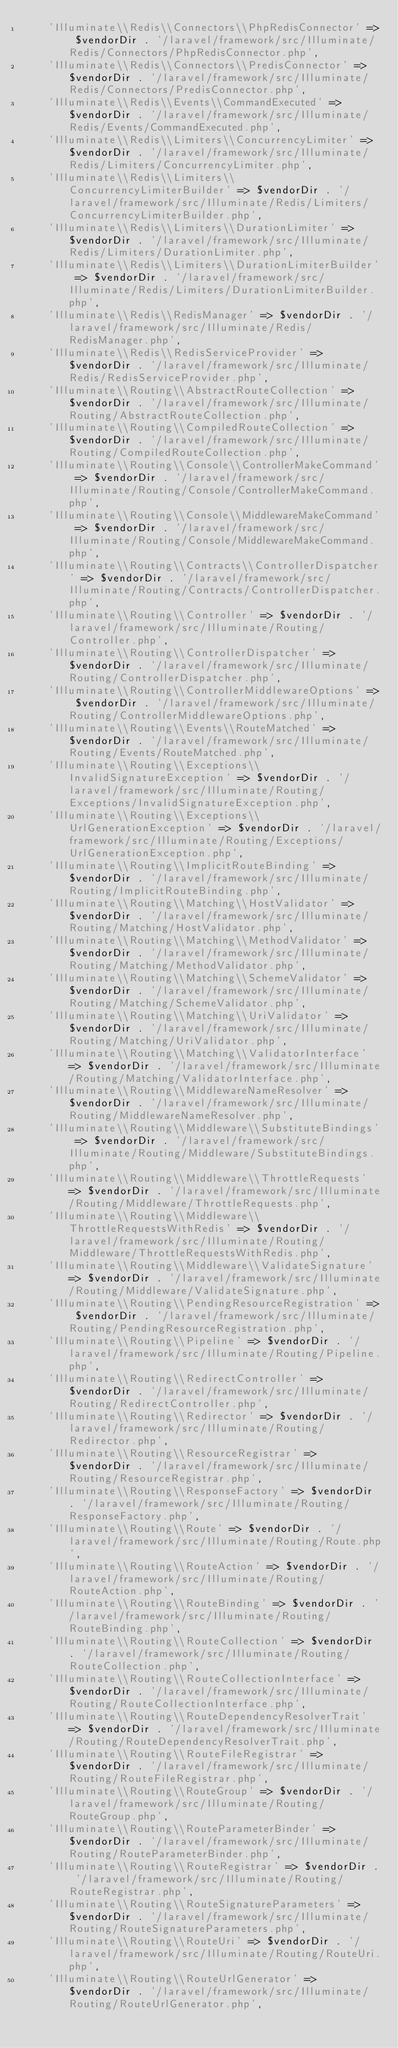Convert code to text. <code><loc_0><loc_0><loc_500><loc_500><_PHP_>    'Illuminate\\Redis\\Connectors\\PhpRedisConnector' => $vendorDir . '/laravel/framework/src/Illuminate/Redis/Connectors/PhpRedisConnector.php',
    'Illuminate\\Redis\\Connectors\\PredisConnector' => $vendorDir . '/laravel/framework/src/Illuminate/Redis/Connectors/PredisConnector.php',
    'Illuminate\\Redis\\Events\\CommandExecuted' => $vendorDir . '/laravel/framework/src/Illuminate/Redis/Events/CommandExecuted.php',
    'Illuminate\\Redis\\Limiters\\ConcurrencyLimiter' => $vendorDir . '/laravel/framework/src/Illuminate/Redis/Limiters/ConcurrencyLimiter.php',
    'Illuminate\\Redis\\Limiters\\ConcurrencyLimiterBuilder' => $vendorDir . '/laravel/framework/src/Illuminate/Redis/Limiters/ConcurrencyLimiterBuilder.php',
    'Illuminate\\Redis\\Limiters\\DurationLimiter' => $vendorDir . '/laravel/framework/src/Illuminate/Redis/Limiters/DurationLimiter.php',
    'Illuminate\\Redis\\Limiters\\DurationLimiterBuilder' => $vendorDir . '/laravel/framework/src/Illuminate/Redis/Limiters/DurationLimiterBuilder.php',
    'Illuminate\\Redis\\RedisManager' => $vendorDir . '/laravel/framework/src/Illuminate/Redis/RedisManager.php',
    'Illuminate\\Redis\\RedisServiceProvider' => $vendorDir . '/laravel/framework/src/Illuminate/Redis/RedisServiceProvider.php',
    'Illuminate\\Routing\\AbstractRouteCollection' => $vendorDir . '/laravel/framework/src/Illuminate/Routing/AbstractRouteCollection.php',
    'Illuminate\\Routing\\CompiledRouteCollection' => $vendorDir . '/laravel/framework/src/Illuminate/Routing/CompiledRouteCollection.php',
    'Illuminate\\Routing\\Console\\ControllerMakeCommand' => $vendorDir . '/laravel/framework/src/Illuminate/Routing/Console/ControllerMakeCommand.php',
    'Illuminate\\Routing\\Console\\MiddlewareMakeCommand' => $vendorDir . '/laravel/framework/src/Illuminate/Routing/Console/MiddlewareMakeCommand.php',
    'Illuminate\\Routing\\Contracts\\ControllerDispatcher' => $vendorDir . '/laravel/framework/src/Illuminate/Routing/Contracts/ControllerDispatcher.php',
    'Illuminate\\Routing\\Controller' => $vendorDir . '/laravel/framework/src/Illuminate/Routing/Controller.php',
    'Illuminate\\Routing\\ControllerDispatcher' => $vendorDir . '/laravel/framework/src/Illuminate/Routing/ControllerDispatcher.php',
    'Illuminate\\Routing\\ControllerMiddlewareOptions' => $vendorDir . '/laravel/framework/src/Illuminate/Routing/ControllerMiddlewareOptions.php',
    'Illuminate\\Routing\\Events\\RouteMatched' => $vendorDir . '/laravel/framework/src/Illuminate/Routing/Events/RouteMatched.php',
    'Illuminate\\Routing\\Exceptions\\InvalidSignatureException' => $vendorDir . '/laravel/framework/src/Illuminate/Routing/Exceptions/InvalidSignatureException.php',
    'Illuminate\\Routing\\Exceptions\\UrlGenerationException' => $vendorDir . '/laravel/framework/src/Illuminate/Routing/Exceptions/UrlGenerationException.php',
    'Illuminate\\Routing\\ImplicitRouteBinding' => $vendorDir . '/laravel/framework/src/Illuminate/Routing/ImplicitRouteBinding.php',
    'Illuminate\\Routing\\Matching\\HostValidator' => $vendorDir . '/laravel/framework/src/Illuminate/Routing/Matching/HostValidator.php',
    'Illuminate\\Routing\\Matching\\MethodValidator' => $vendorDir . '/laravel/framework/src/Illuminate/Routing/Matching/MethodValidator.php',
    'Illuminate\\Routing\\Matching\\SchemeValidator' => $vendorDir . '/laravel/framework/src/Illuminate/Routing/Matching/SchemeValidator.php',
    'Illuminate\\Routing\\Matching\\UriValidator' => $vendorDir . '/laravel/framework/src/Illuminate/Routing/Matching/UriValidator.php',
    'Illuminate\\Routing\\Matching\\ValidatorInterface' => $vendorDir . '/laravel/framework/src/Illuminate/Routing/Matching/ValidatorInterface.php',
    'Illuminate\\Routing\\MiddlewareNameResolver' => $vendorDir . '/laravel/framework/src/Illuminate/Routing/MiddlewareNameResolver.php',
    'Illuminate\\Routing\\Middleware\\SubstituteBindings' => $vendorDir . '/laravel/framework/src/Illuminate/Routing/Middleware/SubstituteBindings.php',
    'Illuminate\\Routing\\Middleware\\ThrottleRequests' => $vendorDir . '/laravel/framework/src/Illuminate/Routing/Middleware/ThrottleRequests.php',
    'Illuminate\\Routing\\Middleware\\ThrottleRequestsWithRedis' => $vendorDir . '/laravel/framework/src/Illuminate/Routing/Middleware/ThrottleRequestsWithRedis.php',
    'Illuminate\\Routing\\Middleware\\ValidateSignature' => $vendorDir . '/laravel/framework/src/Illuminate/Routing/Middleware/ValidateSignature.php',
    'Illuminate\\Routing\\PendingResourceRegistration' => $vendorDir . '/laravel/framework/src/Illuminate/Routing/PendingResourceRegistration.php',
    'Illuminate\\Routing\\Pipeline' => $vendorDir . '/laravel/framework/src/Illuminate/Routing/Pipeline.php',
    'Illuminate\\Routing\\RedirectController' => $vendorDir . '/laravel/framework/src/Illuminate/Routing/RedirectController.php',
    'Illuminate\\Routing\\Redirector' => $vendorDir . '/laravel/framework/src/Illuminate/Routing/Redirector.php',
    'Illuminate\\Routing\\ResourceRegistrar' => $vendorDir . '/laravel/framework/src/Illuminate/Routing/ResourceRegistrar.php',
    'Illuminate\\Routing\\ResponseFactory' => $vendorDir . '/laravel/framework/src/Illuminate/Routing/ResponseFactory.php',
    'Illuminate\\Routing\\Route' => $vendorDir . '/laravel/framework/src/Illuminate/Routing/Route.php',
    'Illuminate\\Routing\\RouteAction' => $vendorDir . '/laravel/framework/src/Illuminate/Routing/RouteAction.php',
    'Illuminate\\Routing\\RouteBinding' => $vendorDir . '/laravel/framework/src/Illuminate/Routing/RouteBinding.php',
    'Illuminate\\Routing\\RouteCollection' => $vendorDir . '/laravel/framework/src/Illuminate/Routing/RouteCollection.php',
    'Illuminate\\Routing\\RouteCollectionInterface' => $vendorDir . '/laravel/framework/src/Illuminate/Routing/RouteCollectionInterface.php',
    'Illuminate\\Routing\\RouteDependencyResolverTrait' => $vendorDir . '/laravel/framework/src/Illuminate/Routing/RouteDependencyResolverTrait.php',
    'Illuminate\\Routing\\RouteFileRegistrar' => $vendorDir . '/laravel/framework/src/Illuminate/Routing/RouteFileRegistrar.php',
    'Illuminate\\Routing\\RouteGroup' => $vendorDir . '/laravel/framework/src/Illuminate/Routing/RouteGroup.php',
    'Illuminate\\Routing\\RouteParameterBinder' => $vendorDir . '/laravel/framework/src/Illuminate/Routing/RouteParameterBinder.php',
    'Illuminate\\Routing\\RouteRegistrar' => $vendorDir . '/laravel/framework/src/Illuminate/Routing/RouteRegistrar.php',
    'Illuminate\\Routing\\RouteSignatureParameters' => $vendorDir . '/laravel/framework/src/Illuminate/Routing/RouteSignatureParameters.php',
    'Illuminate\\Routing\\RouteUri' => $vendorDir . '/laravel/framework/src/Illuminate/Routing/RouteUri.php',
    'Illuminate\\Routing\\RouteUrlGenerator' => $vendorDir . '/laravel/framework/src/Illuminate/Routing/RouteUrlGenerator.php',</code> 